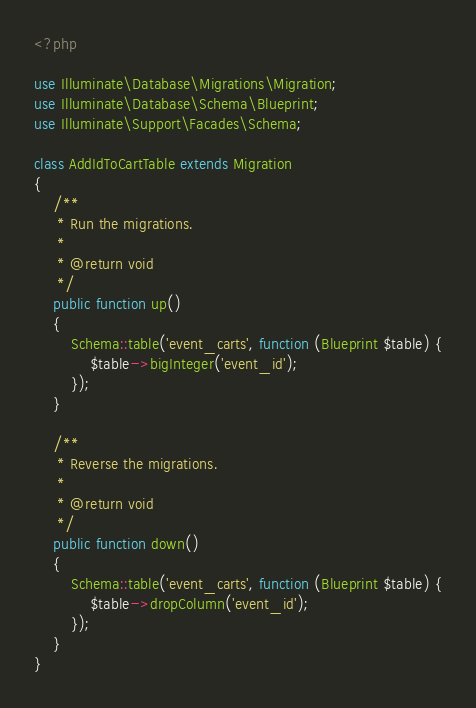Convert code to text. <code><loc_0><loc_0><loc_500><loc_500><_PHP_><?php

use Illuminate\Database\Migrations\Migration;
use Illuminate\Database\Schema\Blueprint;
use Illuminate\Support\Facades\Schema;

class AddIdToCartTable extends Migration
{
    /**
     * Run the migrations.
     *
     * @return void
     */
    public function up()
    {
        Schema::table('event_carts', function (Blueprint $table) {
            $table->bigInteger('event_id');
        });
    }

    /**
     * Reverse the migrations.
     *
     * @return void
     */
    public function down()
    {
        Schema::table('event_carts', function (Blueprint $table) {
            $table->dropColumn('event_id');
        });
    }
}
</code> 